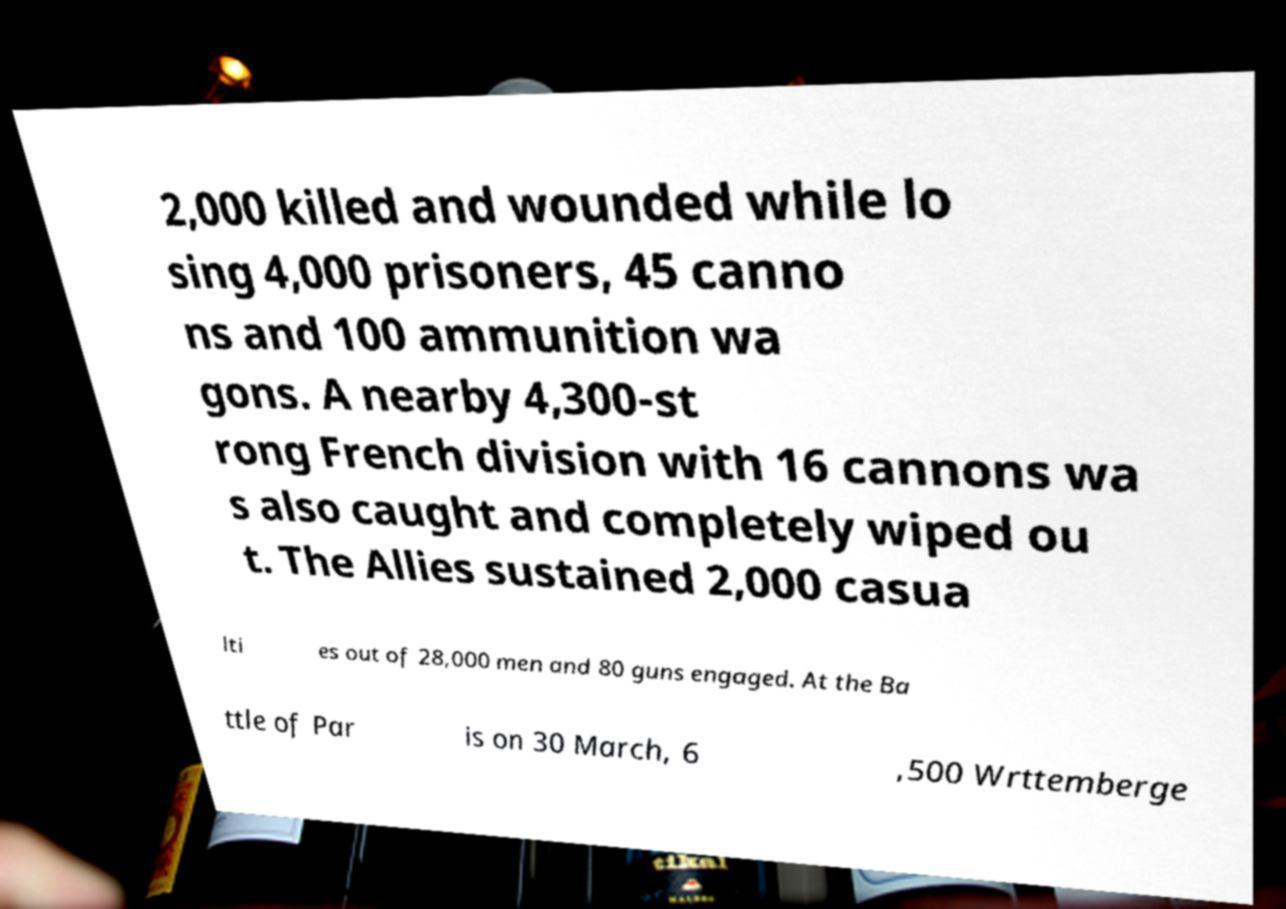What messages or text are displayed in this image? I need them in a readable, typed format. 2,000 killed and wounded while lo sing 4,000 prisoners, 45 canno ns and 100 ammunition wa gons. A nearby 4,300-st rong French division with 16 cannons wa s also caught and completely wiped ou t. The Allies sustained 2,000 casua lti es out of 28,000 men and 80 guns engaged. At the Ba ttle of Par is on 30 March, 6 ,500 Wrttemberge 